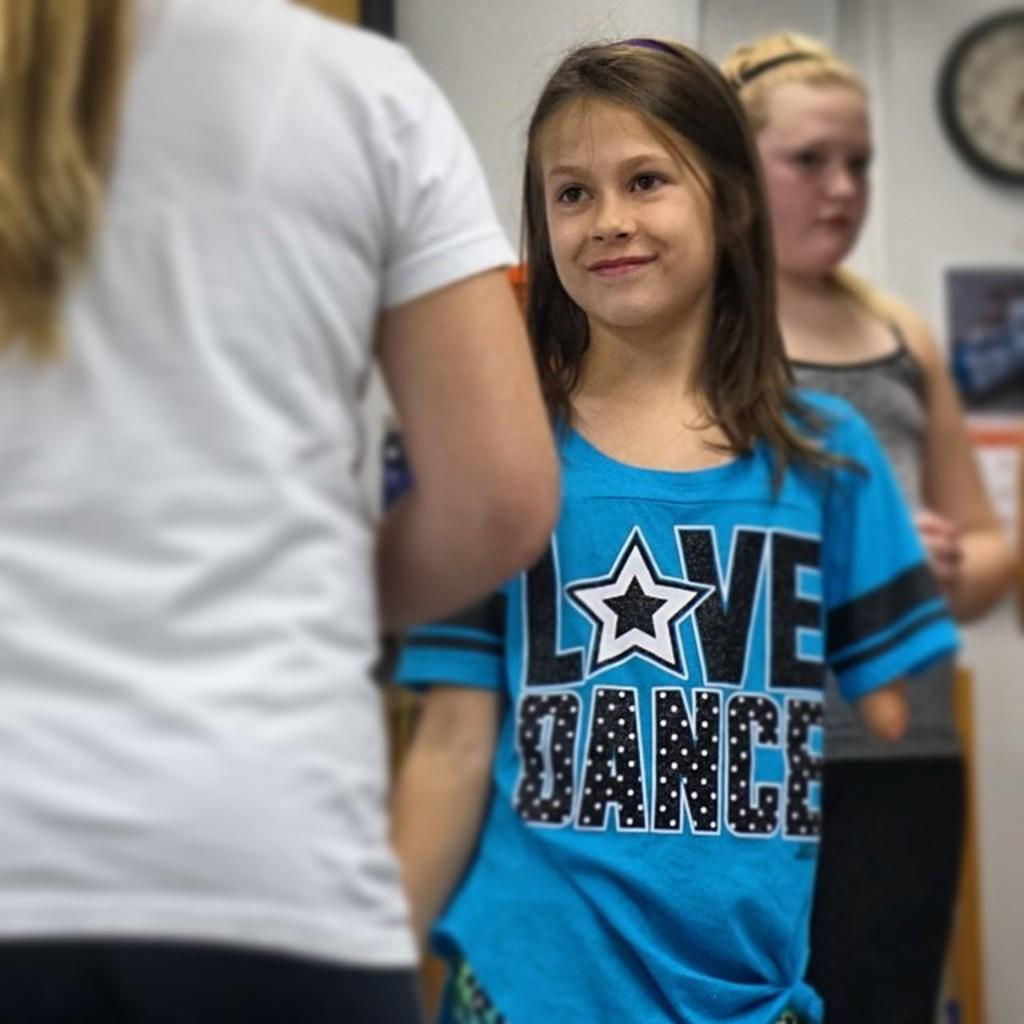Who can be seen in the image? There are people in the image. Can you describe the girl in the image? The girl in the image is smiling. What is visible in the background of the image? There is a wall and objects visible in the background of the image. What type of glass can be seen in the girl's hand in the image? There is no glass present in the girl's hand or in the image. What kind of breakfast is being served in the image? There is no breakfast visible in the image. 